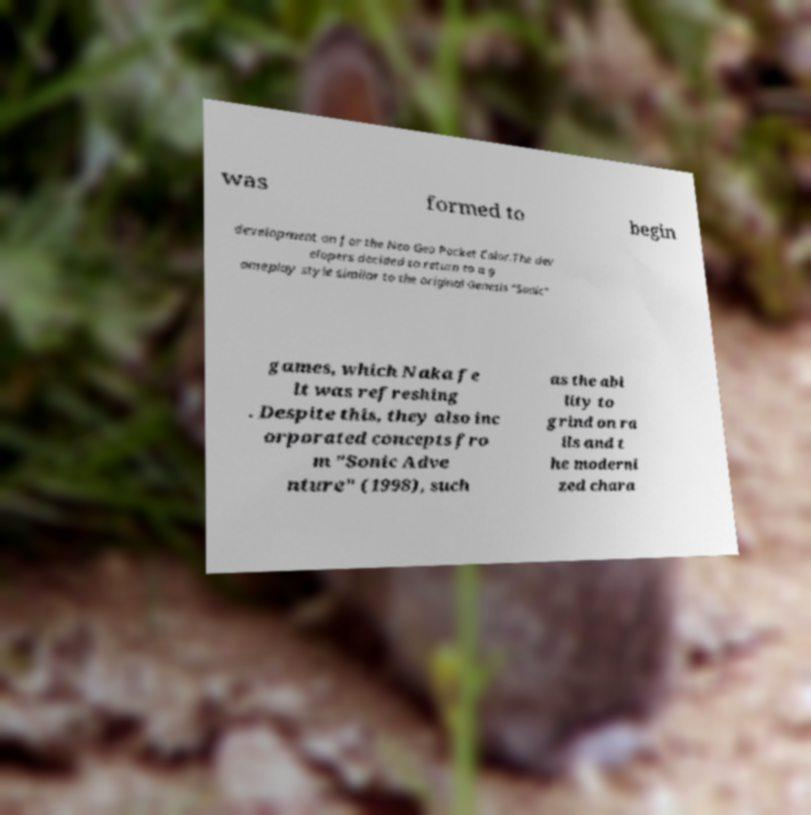Can you accurately transcribe the text from the provided image for me? was formed to begin development on for the Neo Geo Pocket Color.The dev elopers decided to return to a g ameplay style similar to the original Genesis "Sonic" games, which Naka fe lt was refreshing . Despite this, they also inc orporated concepts fro m "Sonic Adve nture" (1998), such as the abi lity to grind on ra ils and t he moderni zed chara 